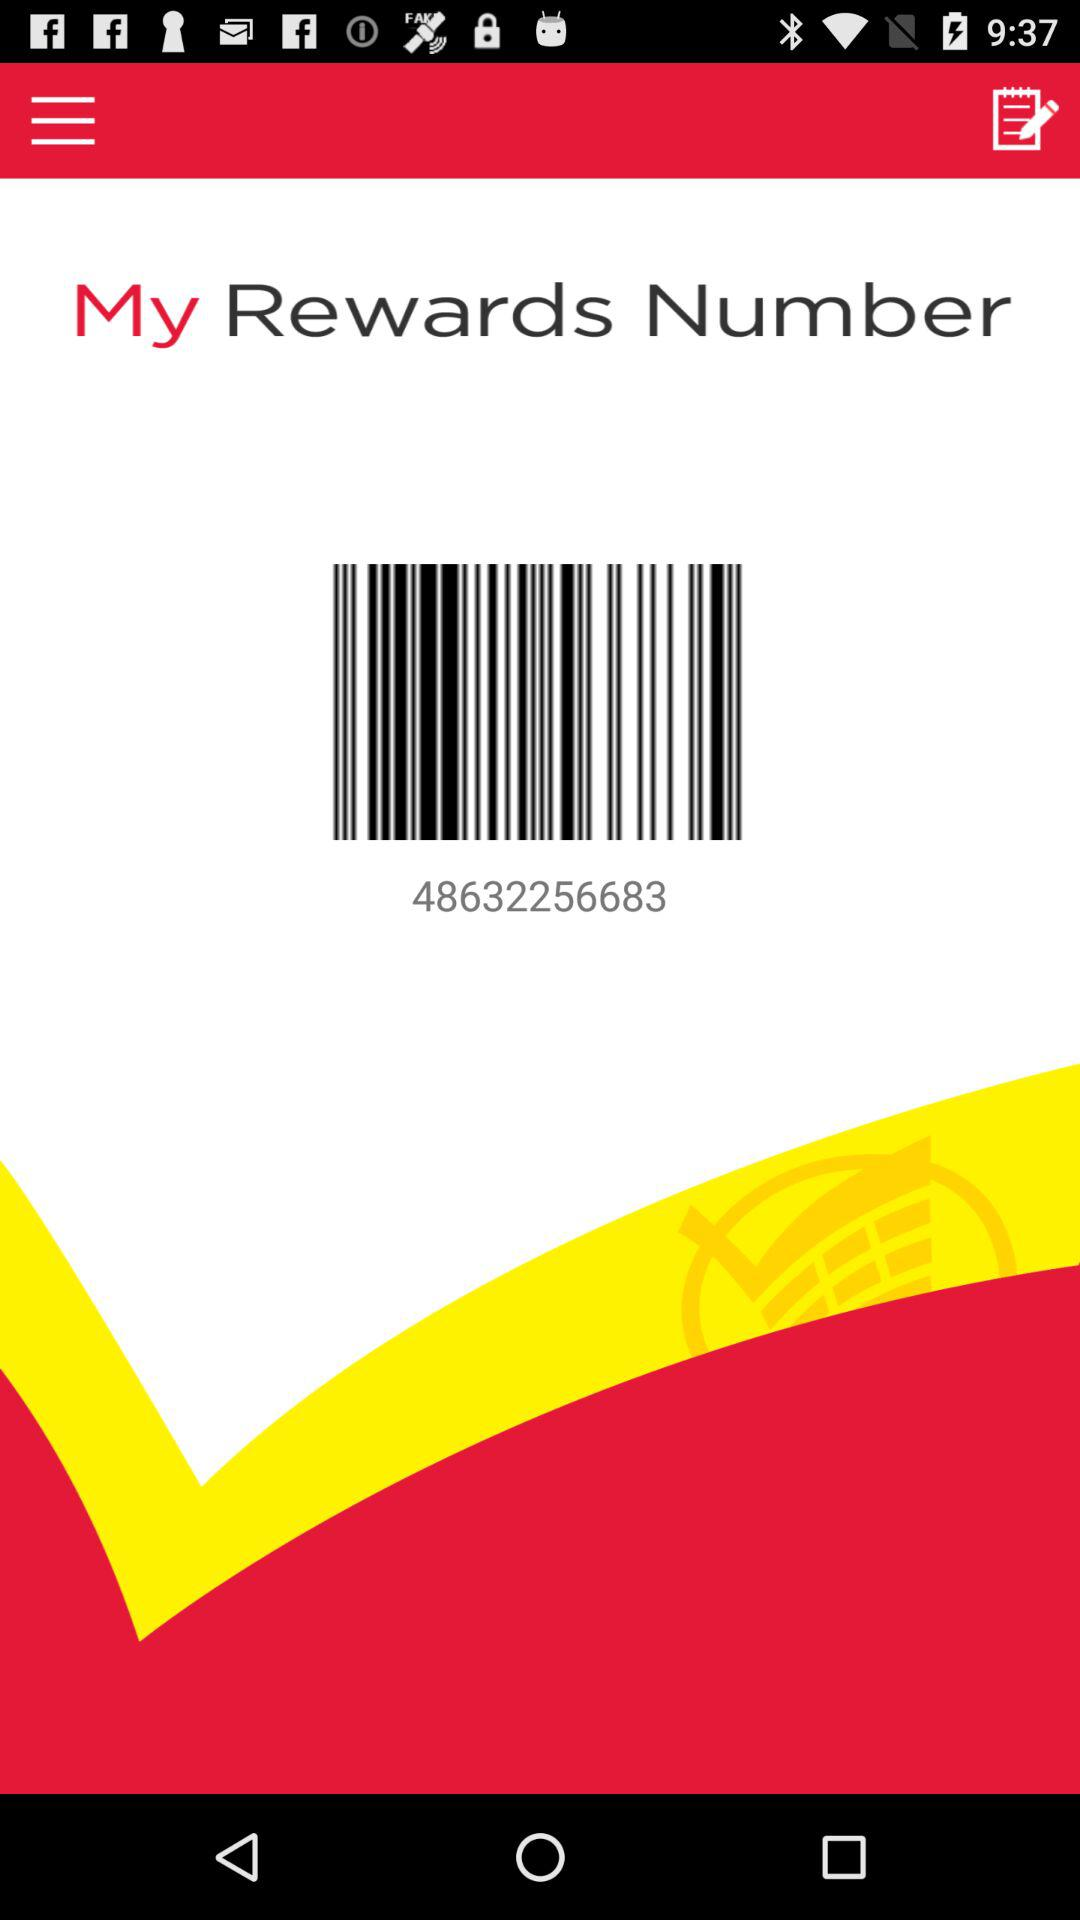What is the number? The number is 48632256683. 